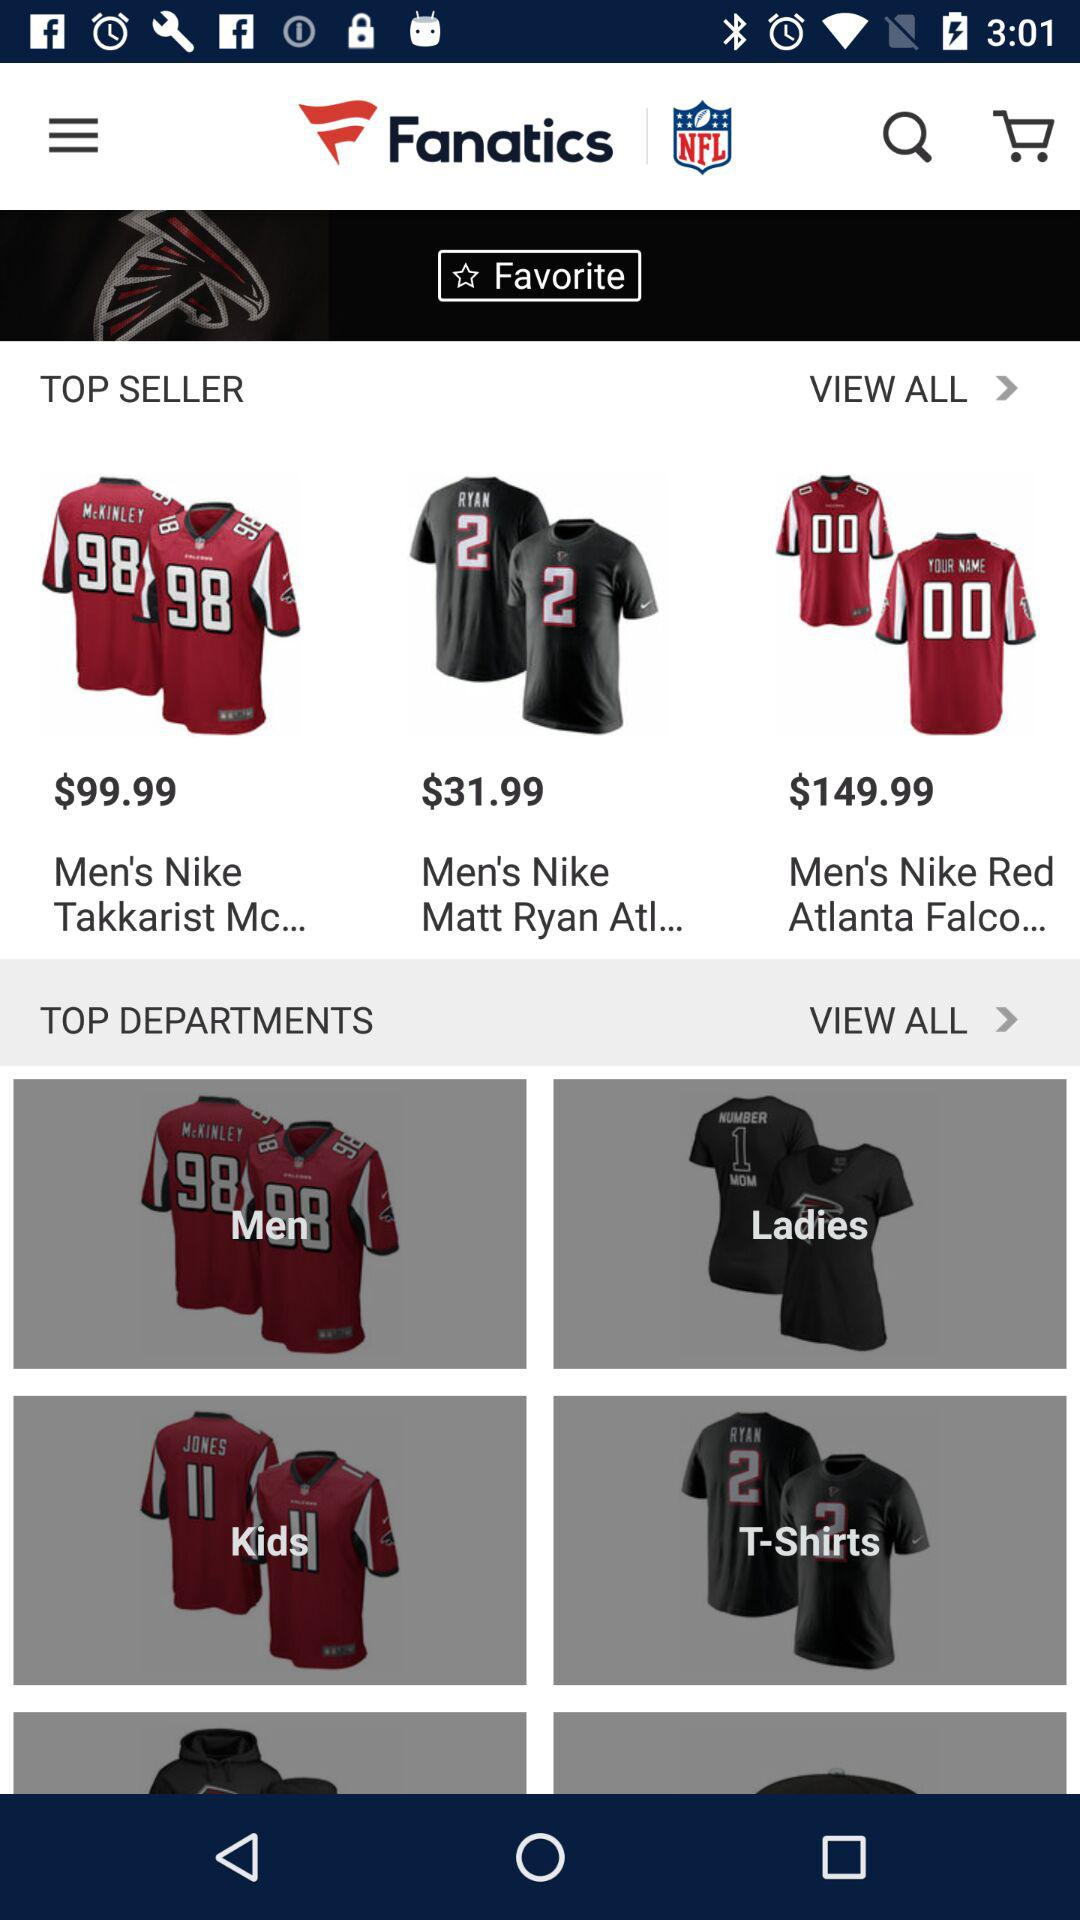How many more items are in the top departments section than the top sellers section?
Answer the question using a single word or phrase. 3 